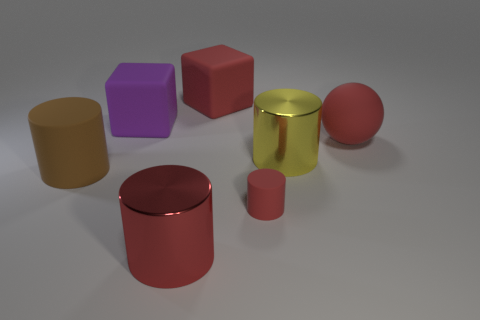What color is the rubber ball that is the same size as the red matte block?
Make the answer very short. Red. The large matte object in front of the big matte ball right of the yellow object is what color?
Your answer should be very brief. Brown. Does the object in front of the tiny red cylinder have the same color as the sphere?
Ensure brevity in your answer.  Yes. There is a metal object on the right side of the red cylinder left of the red matte thing in front of the big yellow metal cylinder; what shape is it?
Your response must be concise. Cylinder. What number of big cubes are in front of the large red object behind the large purple matte block?
Provide a short and direct response. 1. Is the material of the big purple thing the same as the yellow cylinder?
Ensure brevity in your answer.  No. There is a big block on the right side of the red metallic cylinder that is in front of the small red cylinder; what number of matte cubes are in front of it?
Offer a terse response. 1. What color is the big rubber object in front of the red sphere?
Give a very brief answer. Brown. The large yellow object to the right of the large red thing behind the red sphere is what shape?
Offer a terse response. Cylinder. Do the tiny cylinder and the rubber ball have the same color?
Make the answer very short. Yes. 